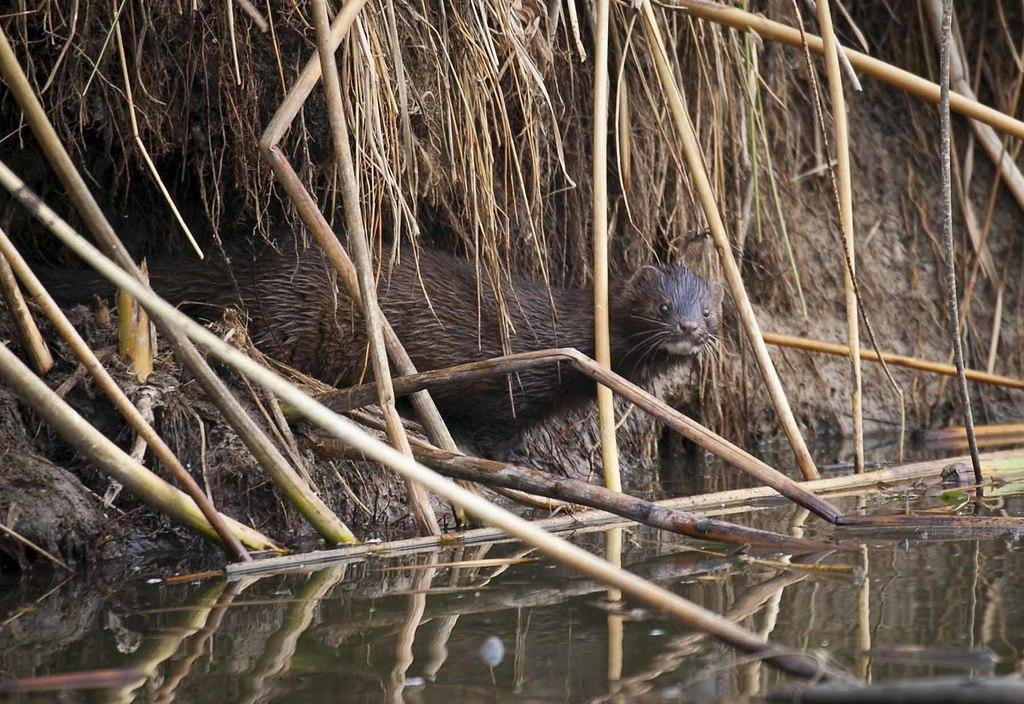What animal is located in the middle of the image? There is a mongoose in the middle of the image. What can be seen at the bottom of the image? There is water at the bottom of the image. What part of the plants is visible at the top of the image? The stems of plants are visible at the top of the image. How many zebras can be seen grazing near the water in the image? There are no zebras present in the image. Can you describe the trail left by the ladybug in the image? There is no ladybug or trail visible in the image. 